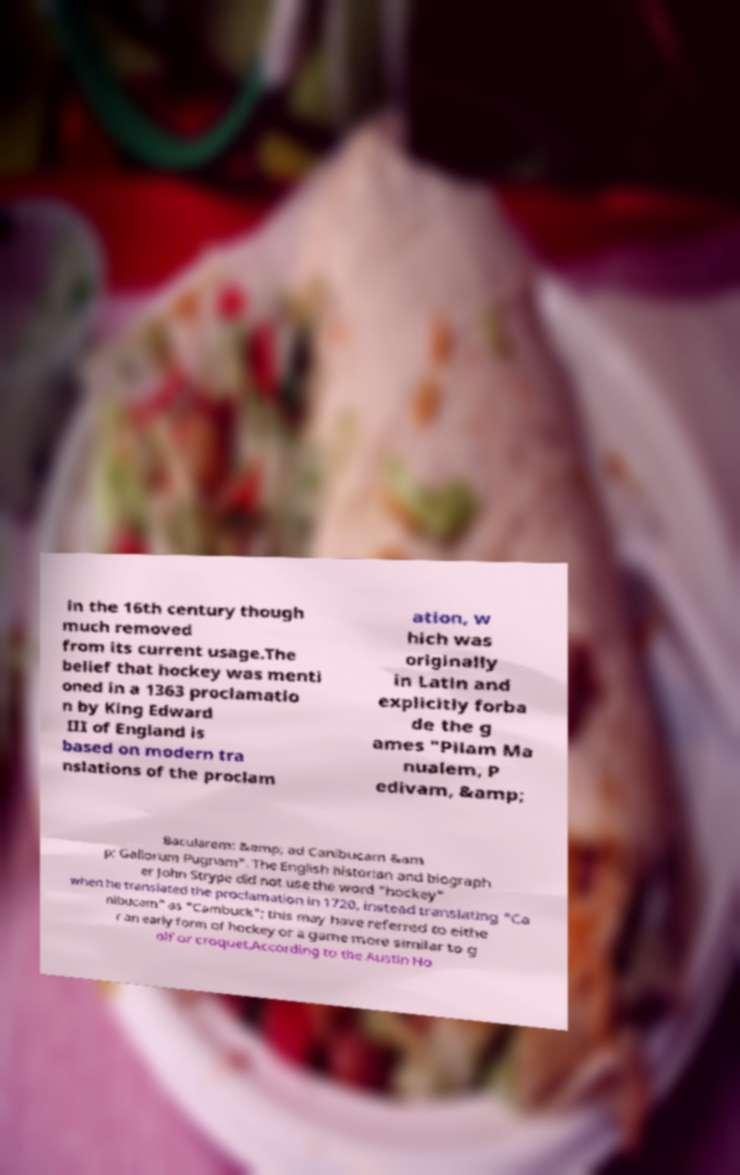I need the written content from this picture converted into text. Can you do that? in the 16th century though much removed from its current usage.The belief that hockey was menti oned in a 1363 proclamatio n by King Edward III of England is based on modern tra nslations of the proclam ation, w hich was originally in Latin and explicitly forba de the g ames "Pilam Ma nualem, P edivam, &amp; Bacularem: &amp; ad Canibucam &am p; Gallorum Pugnam". The English historian and biograph er John Strype did not use the word "hockey" when he translated the proclamation in 1720, instead translating "Ca nibucam" as "Cambuck"; this may have referred to eithe r an early form of hockey or a game more similar to g olf or croquet.According to the Austin Ho 